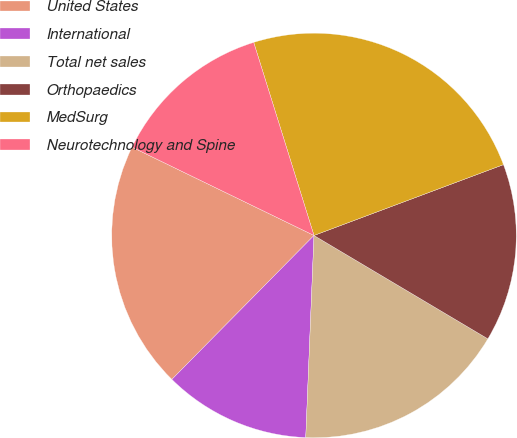Convert chart. <chart><loc_0><loc_0><loc_500><loc_500><pie_chart><fcel>United States<fcel>International<fcel>Total net sales<fcel>Orthopaedics<fcel>MedSurg<fcel>Neurotechnology and Spine<nl><fcel>19.79%<fcel>11.75%<fcel>17.11%<fcel>14.23%<fcel>24.12%<fcel>12.99%<nl></chart> 